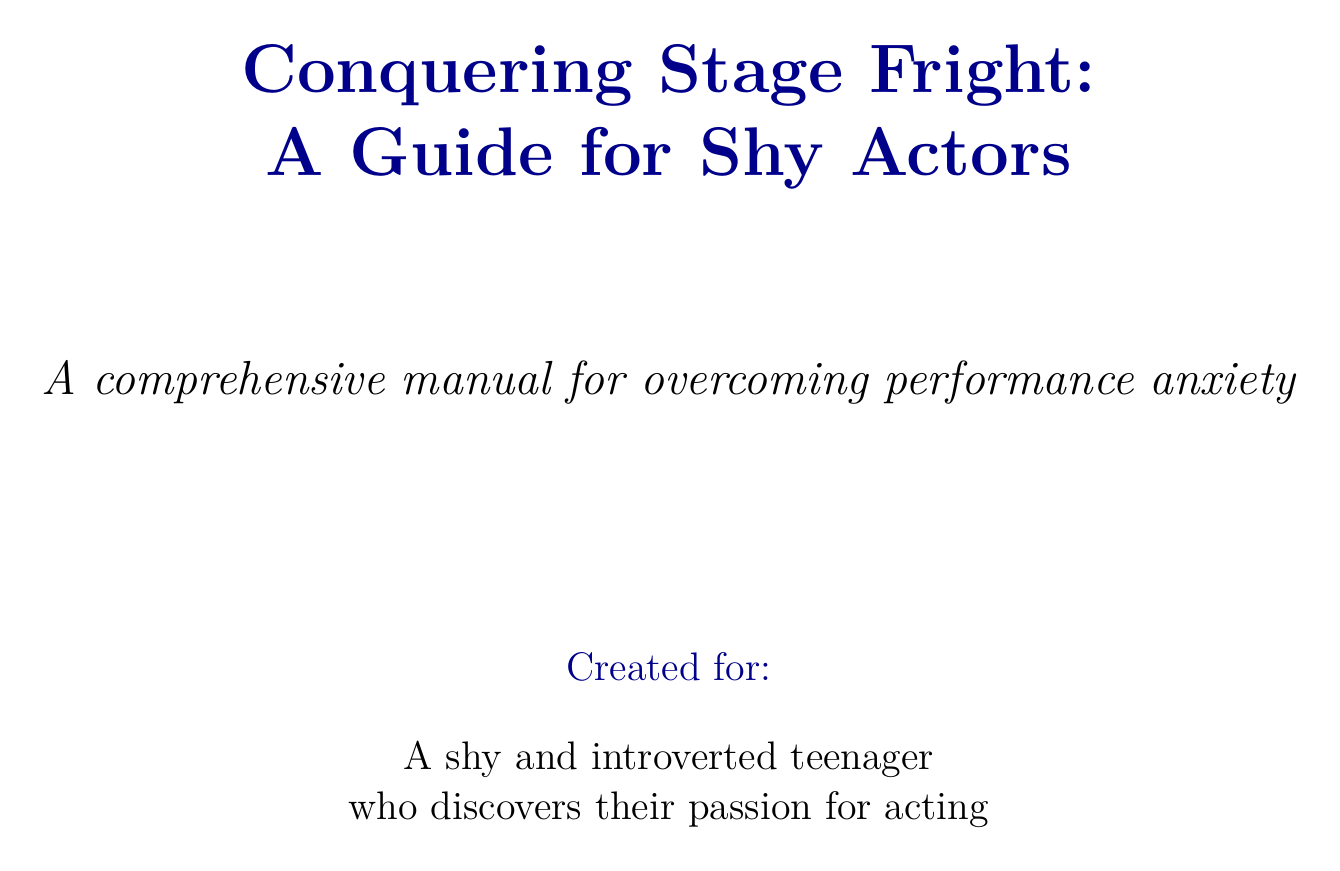what is the title of the document? The title of the document is found in the header section, which states the name of the guide.
Answer: Conquering Stage Fright: A Guide for Shy Actors how many chapters are in the document? The total number of chapters can be counted from the structured list in the document.
Answer: Six what technique helps identify negative thoughts about performing? This technique is specified in the Mental Techniques section for addressing harmful thoughts related to performance.
Answer: Cognitive Restructuring who is one case study mentioned in the document? The case studies section lists examples of successful actors who overcame anxiety.
Answer: Emma Stone which exercise involves practicing in front of a mirror? It is described under the Practical Exercises section related to self-observation during rehearsal.
Answer: Mirror Work what is the purpose of the Calm mobile app? The description in the Resources section outlines its specific use for managing performance-related anxiety.
Answer: Meditation and relaxation what does the conclusion emphasize about overcoming stage fright? The final thoughts in the conclusion summarize the approach required to tackle performance anxiety.
Answer: Patience and practice which chapter discusses creating a pre-performance ritual? This chapter provides insights and strategies for preparing before performing.
Answer: Preparing for Performances 